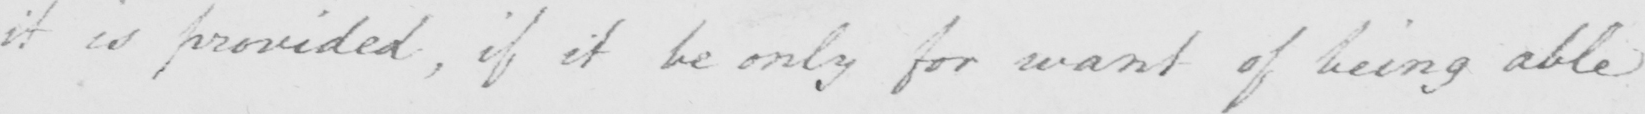Transcribe the text shown in this historical manuscript line. it is provided , if it be only for want of being able 